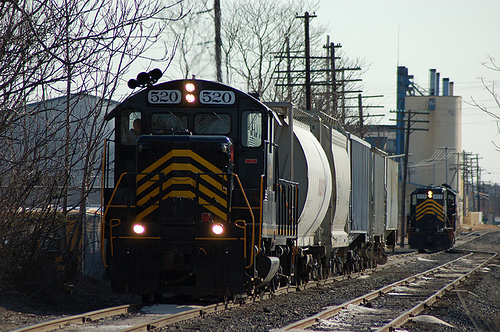<image>
Is there a train next to the tower? Yes. The train is positioned adjacent to the tower, located nearby in the same general area. Is there a train under the trees? Yes. The train is positioned underneath the trees, with the trees above it in the vertical space. 